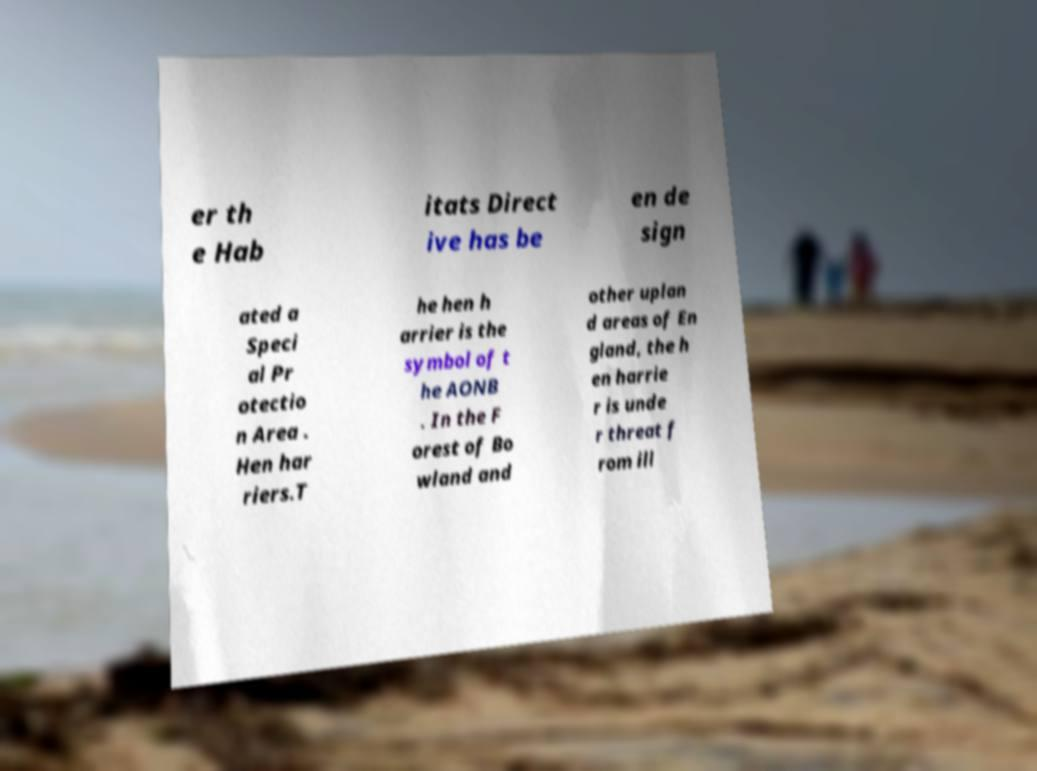I need the written content from this picture converted into text. Can you do that? er th e Hab itats Direct ive has be en de sign ated a Speci al Pr otectio n Area . Hen har riers.T he hen h arrier is the symbol of t he AONB . In the F orest of Bo wland and other uplan d areas of En gland, the h en harrie r is unde r threat f rom ill 